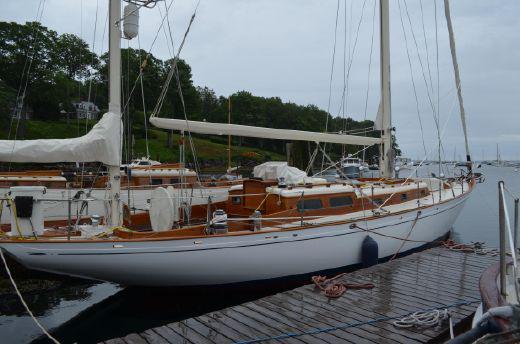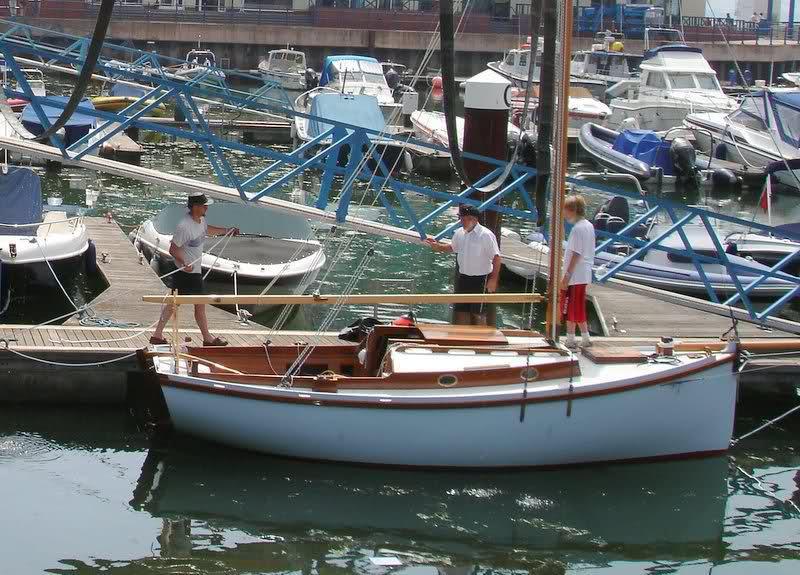The first image is the image on the left, the second image is the image on the right. Evaluate the accuracy of this statement regarding the images: "n at least one image there are two red sails on a boat in the water.". Is it true? Answer yes or no. No. The first image is the image on the left, the second image is the image on the right. For the images displayed, is the sentence "A sailboat on open water in one image has red sails and at least one person on the boat." factually correct? Answer yes or no. No. 